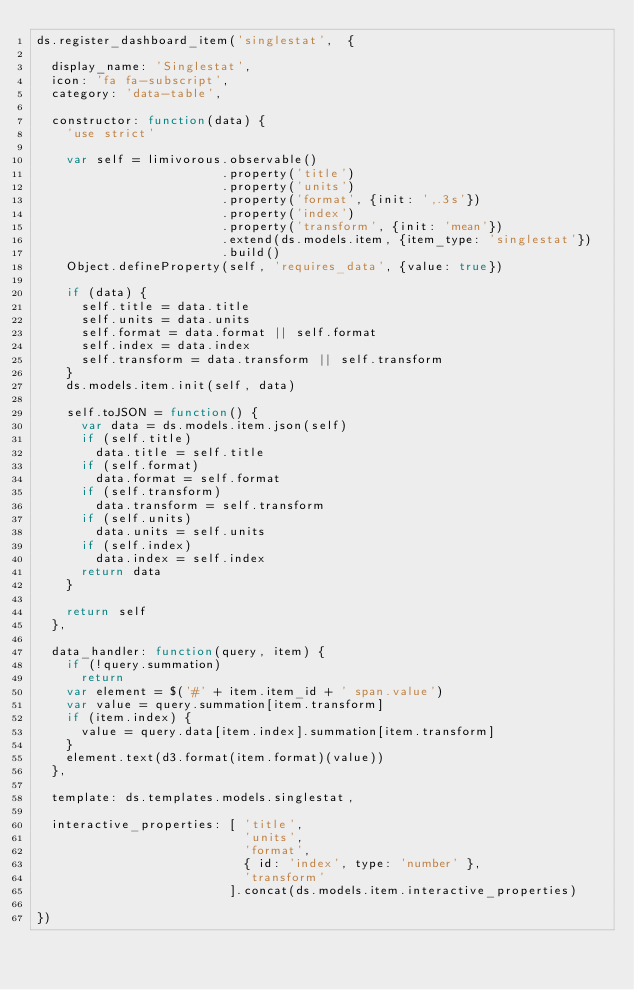Convert code to text. <code><loc_0><loc_0><loc_500><loc_500><_JavaScript_>ds.register_dashboard_item('singlestat',  {

  display_name: 'Singlestat',
  icon: 'fa fa-subscript',
  category: 'data-table',

  constructor: function(data) {
    'use strict'

    var self = limivorous.observable()
                         .property('title')
                         .property('units')
                         .property('format', {init: ',.3s'})
                         .property('index')
                         .property('transform', {init: 'mean'})
                         .extend(ds.models.item, {item_type: 'singlestat'})
                         .build()
    Object.defineProperty(self, 'requires_data', {value: true})

    if (data) {
      self.title = data.title
      self.units = data.units
      self.format = data.format || self.format
      self.index = data.index
      self.transform = data.transform || self.transform
    }
    ds.models.item.init(self, data)

    self.toJSON = function() {
      var data = ds.models.item.json(self)
      if (self.title)
        data.title = self.title
      if (self.format)
        data.format = self.format
      if (self.transform)
        data.transform = self.transform
      if (self.units)
        data.units = self.units
      if (self.index)
        data.index = self.index
      return data
    }

    return self
  },

  data_handler: function(query, item) {
    if (!query.summation)
      return
    var element = $('#' + item.item_id + ' span.value')
    var value = query.summation[item.transform]
    if (item.index) {
      value = query.data[item.index].summation[item.transform]
    }
    element.text(d3.format(item.format)(value))
  },

  template: ds.templates.models.singlestat,

  interactive_properties: [ 'title',
                            'units',
                            'format',
                            { id: 'index', type: 'number' },
                            'transform'
                          ].concat(ds.models.item.interactive_properties)

})
</code> 